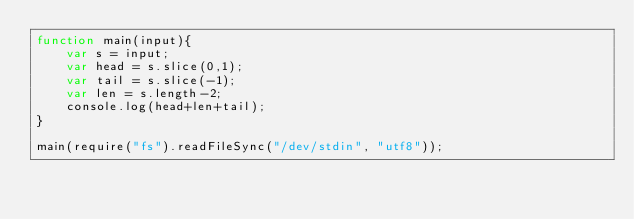Convert code to text. <code><loc_0><loc_0><loc_500><loc_500><_JavaScript_>function main(input){
    var s = input;
    var head = s.slice(0,1);
    var tail = s.slice(-1);
    var len = s.length-2;
    console.log(head+len+tail);
}

main(require("fs").readFileSync("/dev/stdin", "utf8"));</code> 